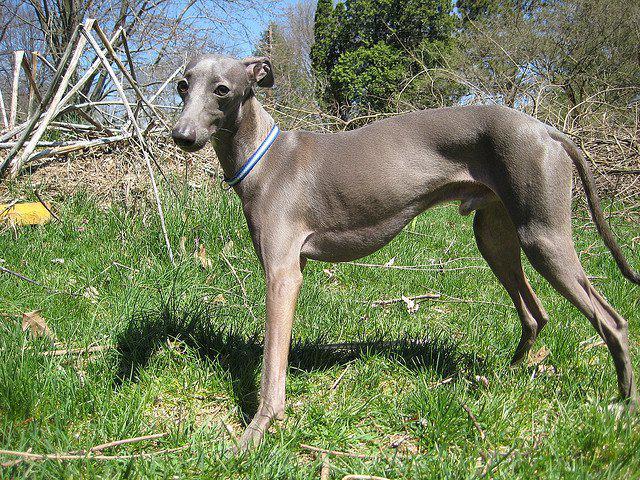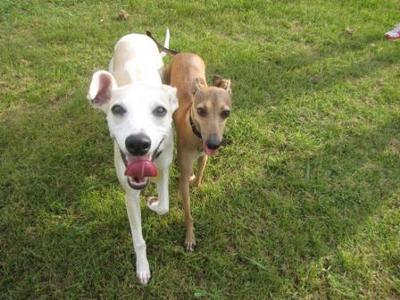The first image is the image on the left, the second image is the image on the right. Examine the images to the left and right. Is the description "An image shows two similarly colored, non-standing dogs side-by-side." accurate? Answer yes or no. No. The first image is the image on the left, the second image is the image on the right. Examine the images to the left and right. Is the description "There are 4 or more dogs, and at least two of them are touching." accurate? Answer yes or no. No. 